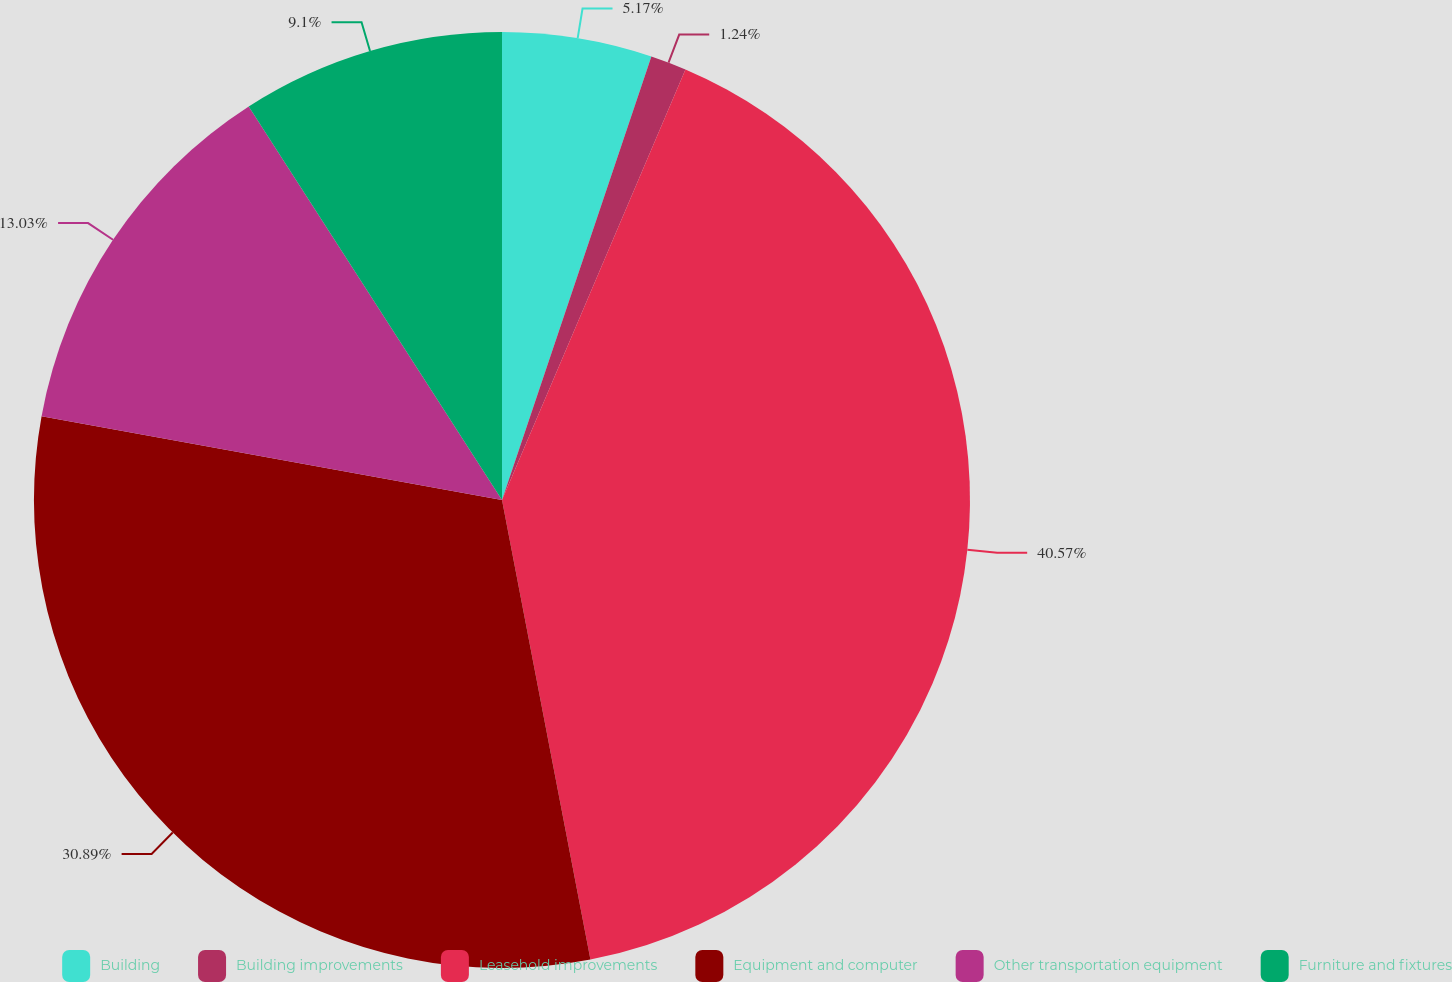Convert chart. <chart><loc_0><loc_0><loc_500><loc_500><pie_chart><fcel>Building<fcel>Building improvements<fcel>Leasehold improvements<fcel>Equipment and computer<fcel>Other transportation equipment<fcel>Furniture and fixtures<nl><fcel>5.17%<fcel>1.24%<fcel>40.56%<fcel>30.89%<fcel>13.03%<fcel>9.1%<nl></chart> 